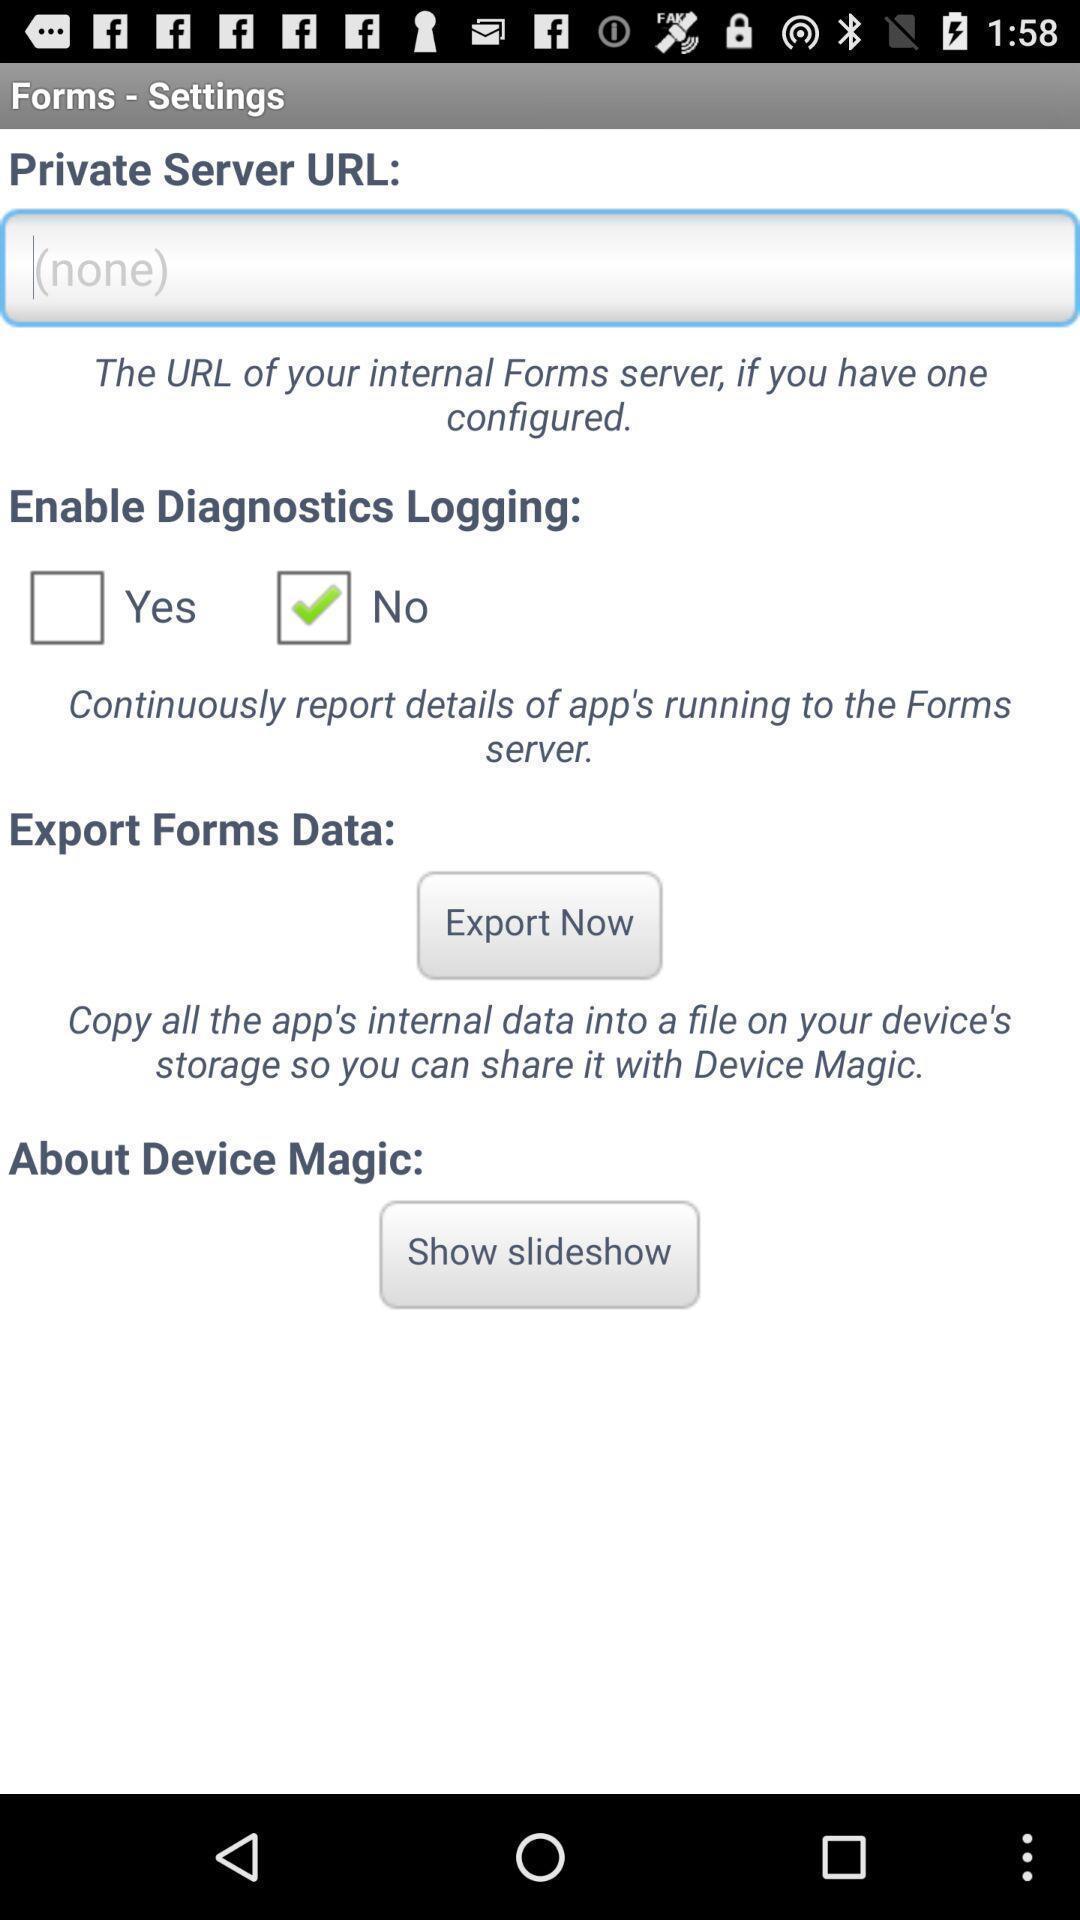Give me a narrative description of this picture. Setting page for setting url and other of forms. 